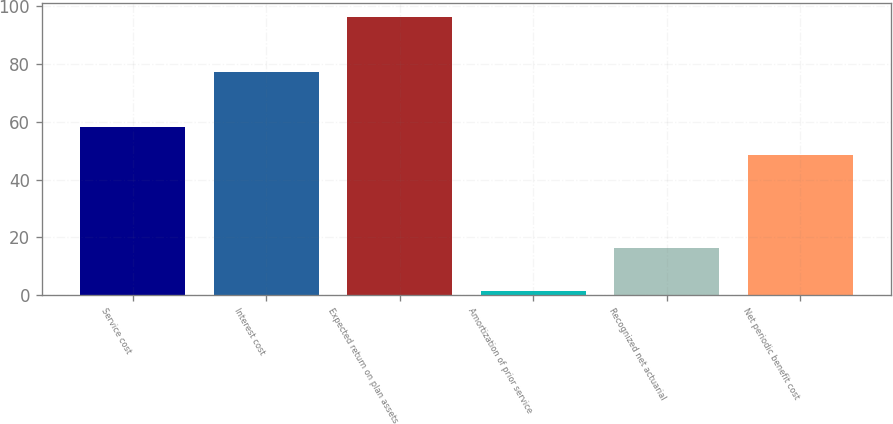Convert chart to OTSL. <chart><loc_0><loc_0><loc_500><loc_500><bar_chart><fcel>Service cost<fcel>Interest cost<fcel>Expected return on plan assets<fcel>Amortization of prior service<fcel>Recognized net actuarial<fcel>Net periodic benefit cost<nl><fcel>58.09<fcel>77.4<fcel>96.2<fcel>1.3<fcel>16.4<fcel>48.6<nl></chart> 